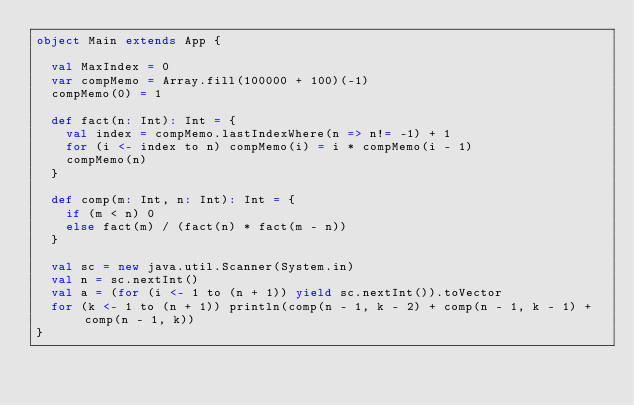<code> <loc_0><loc_0><loc_500><loc_500><_Scala_>object Main extends App {

  val MaxIndex = 0
  var compMemo = Array.fill(100000 + 100)(-1)
  compMemo(0) = 1

  def fact(n: Int): Int = {
    val index = compMemo.lastIndexWhere(n => n!= -1) + 1
    for (i <- index to n) compMemo(i) = i * compMemo(i - 1)
    compMemo(n)
  }

  def comp(m: Int, n: Int): Int = {
    if (m < n) 0
    else fact(m) / (fact(n) * fact(m - n))
  }

  val sc = new java.util.Scanner(System.in)
  val n = sc.nextInt()
  val a = (for (i <- 1 to (n + 1)) yield sc.nextInt()).toVector
  for (k <- 1 to (n + 1)) println(comp(n - 1, k - 2) + comp(n - 1, k - 1) + comp(n - 1, k))
}</code> 